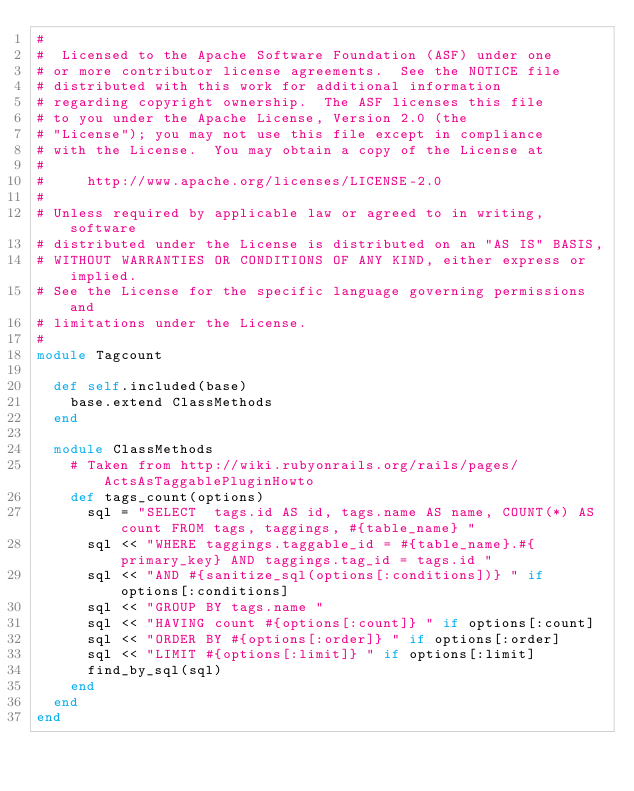<code> <loc_0><loc_0><loc_500><loc_500><_Ruby_>#
#  Licensed to the Apache Software Foundation (ASF) under one
# or more contributor license agreements.  See the NOTICE file
# distributed with this work for additional information
# regarding copyright ownership.  The ASF licenses this file
# to you under the Apache License, Version 2.0 (the
# "License"); you may not use this file except in compliance
# with the License.  You may obtain a copy of the License at
#
#     http://www.apache.org/licenses/LICENSE-2.0
#
# Unless required by applicable law or agreed to in writing, software
# distributed under the License is distributed on an "AS IS" BASIS,
# WITHOUT WARRANTIES OR CONDITIONS OF ANY KIND, either express or implied.
# See the License for the specific language governing permissions and
# limitations under the License.
#
module Tagcount
  
  def self.included(base)
    base.extend ClassMethods
  end
  
  module ClassMethods
    # Taken from http://wiki.rubyonrails.org/rails/pages/ActsAsTaggablePluginHowto
    def tags_count(options)
      sql = "SELECT  tags.id AS id, tags.name AS name, COUNT(*) AS count FROM tags, taggings, #{table_name} " 
      sql << "WHERE taggings.taggable_id = #{table_name}.#{primary_key} AND taggings.tag_id = tags.id " 
      sql << "AND #{sanitize_sql(options[:conditions])} " if options[:conditions]
      sql << "GROUP BY tags.name " 
      sql << "HAVING count #{options[:count]} " if options[:count]
      sql << "ORDER BY #{options[:order]} " if options[:order]
      sql << "LIMIT #{options[:limit]} " if options[:limit]
      find_by_sql(sql)
    end
  end
end
</code> 